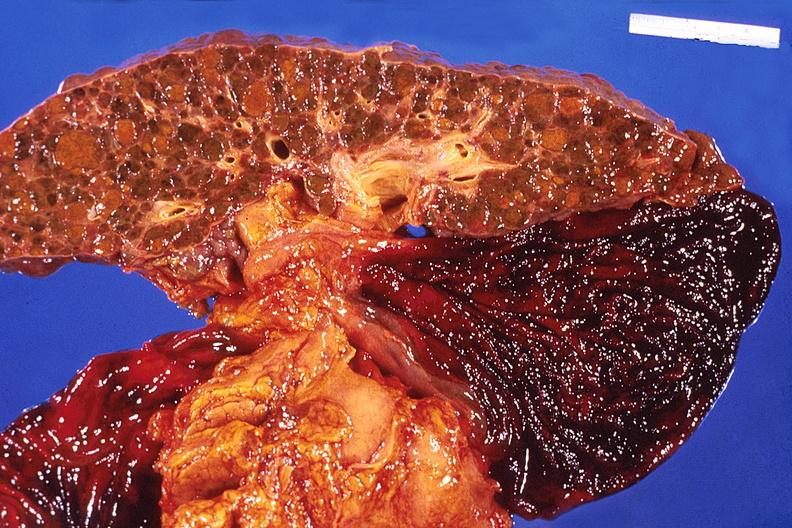does bone, skull show liver, cirrhosis and enlarged gall bladder?
Answer the question using a single word or phrase. No 